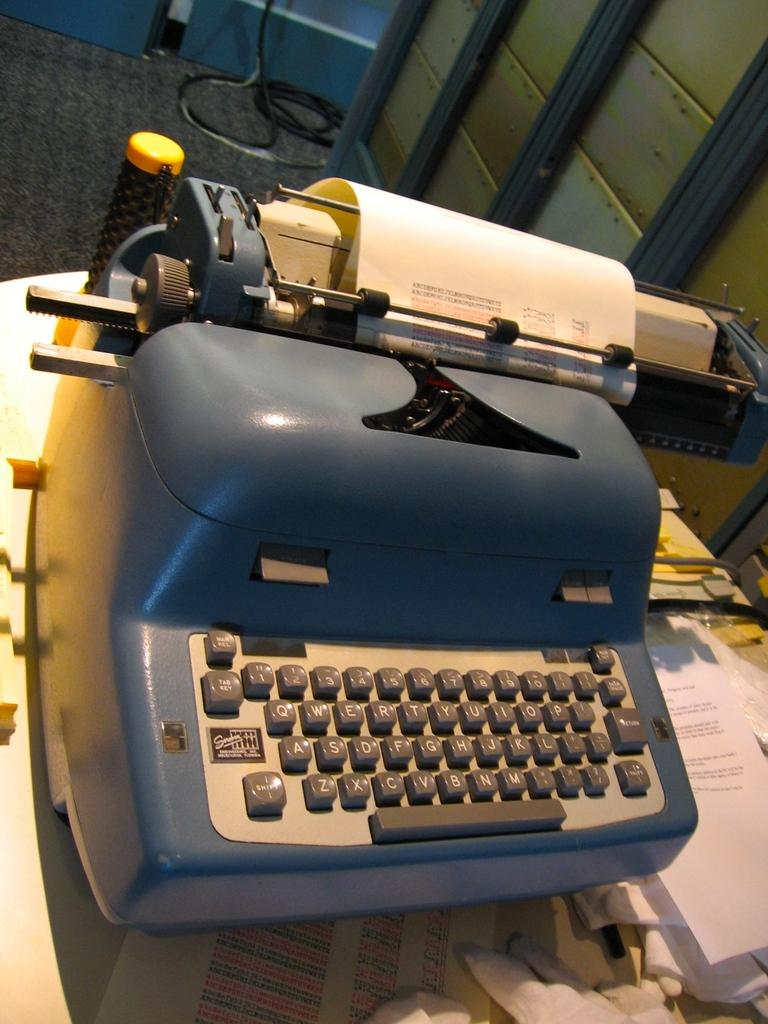<image>
Provide a brief description of the given image. A vintage typewriter with a shift key on the far left. 